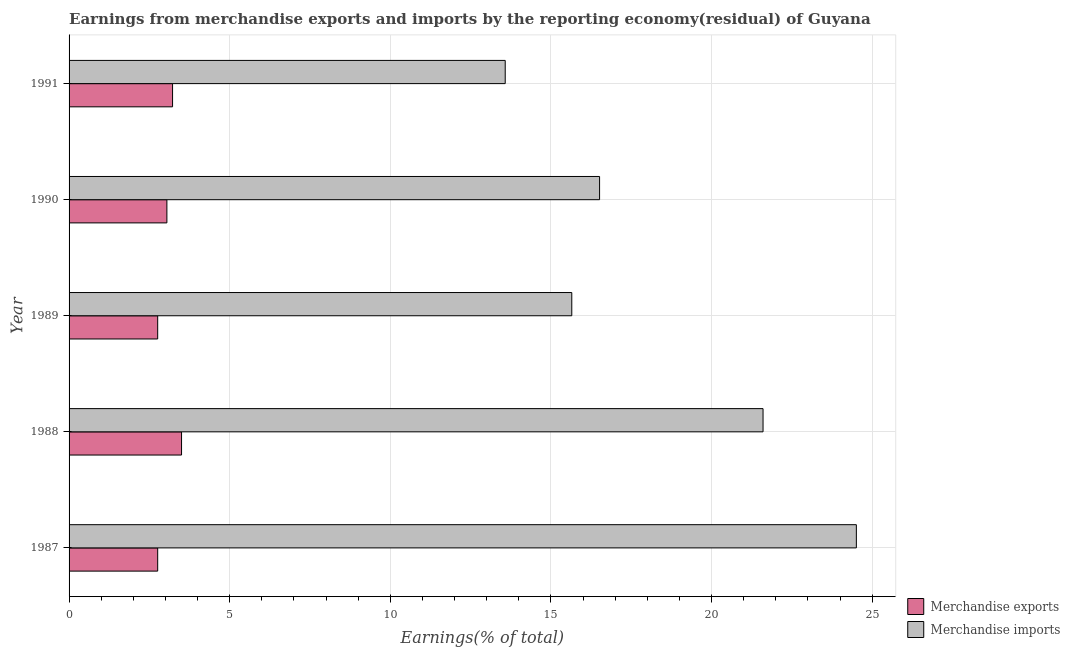How many different coloured bars are there?
Offer a terse response. 2. How many bars are there on the 3rd tick from the bottom?
Offer a very short reply. 2. What is the label of the 5th group of bars from the top?
Ensure brevity in your answer.  1987. In how many cases, is the number of bars for a given year not equal to the number of legend labels?
Your answer should be compact. 0. What is the earnings from merchandise exports in 1990?
Your answer should be very brief. 3.05. Across all years, what is the maximum earnings from merchandise imports?
Give a very brief answer. 24.51. Across all years, what is the minimum earnings from merchandise imports?
Give a very brief answer. 13.58. In which year was the earnings from merchandise exports maximum?
Keep it short and to the point. 1988. What is the total earnings from merchandise exports in the graph?
Provide a short and direct response. 15.28. What is the difference between the earnings from merchandise imports in 1987 and that in 1991?
Offer a terse response. 10.93. What is the difference between the earnings from merchandise exports in 1989 and the earnings from merchandise imports in 1988?
Your answer should be compact. -18.84. What is the average earnings from merchandise imports per year?
Offer a terse response. 18.37. In the year 1988, what is the difference between the earnings from merchandise exports and earnings from merchandise imports?
Offer a very short reply. -18.1. In how many years, is the earnings from merchandise exports greater than 7 %?
Offer a terse response. 0. What is the ratio of the earnings from merchandise exports in 1990 to that in 1991?
Your answer should be very brief. 0.94. Is the difference between the earnings from merchandise exports in 1989 and 1991 greater than the difference between the earnings from merchandise imports in 1989 and 1991?
Offer a very short reply. No. What is the difference between the highest and the second highest earnings from merchandise exports?
Your answer should be compact. 0.28. What is the difference between the highest and the lowest earnings from merchandise exports?
Offer a very short reply. 0.74. What does the 2nd bar from the top in 1990 represents?
Keep it short and to the point. Merchandise exports. Are all the bars in the graph horizontal?
Make the answer very short. Yes. How many years are there in the graph?
Offer a terse response. 5. Are the values on the major ticks of X-axis written in scientific E-notation?
Ensure brevity in your answer.  No. Does the graph contain any zero values?
Your answer should be compact. No. Does the graph contain grids?
Make the answer very short. Yes. How are the legend labels stacked?
Your response must be concise. Vertical. What is the title of the graph?
Your answer should be very brief. Earnings from merchandise exports and imports by the reporting economy(residual) of Guyana. What is the label or title of the X-axis?
Give a very brief answer. Earnings(% of total). What is the Earnings(% of total) of Merchandise exports in 1987?
Ensure brevity in your answer.  2.76. What is the Earnings(% of total) of Merchandise imports in 1987?
Ensure brevity in your answer.  24.51. What is the Earnings(% of total) of Merchandise exports in 1988?
Give a very brief answer. 3.5. What is the Earnings(% of total) in Merchandise imports in 1988?
Your response must be concise. 21.6. What is the Earnings(% of total) of Merchandise exports in 1989?
Your response must be concise. 2.76. What is the Earnings(% of total) in Merchandise imports in 1989?
Your answer should be compact. 15.65. What is the Earnings(% of total) of Merchandise exports in 1990?
Offer a very short reply. 3.05. What is the Earnings(% of total) of Merchandise imports in 1990?
Provide a short and direct response. 16.51. What is the Earnings(% of total) in Merchandise exports in 1991?
Your response must be concise. 3.22. What is the Earnings(% of total) of Merchandise imports in 1991?
Offer a very short reply. 13.58. Across all years, what is the maximum Earnings(% of total) in Merchandise exports?
Your answer should be compact. 3.5. Across all years, what is the maximum Earnings(% of total) of Merchandise imports?
Your response must be concise. 24.51. Across all years, what is the minimum Earnings(% of total) of Merchandise exports?
Provide a succinct answer. 2.76. Across all years, what is the minimum Earnings(% of total) of Merchandise imports?
Ensure brevity in your answer.  13.58. What is the total Earnings(% of total) in Merchandise exports in the graph?
Your response must be concise. 15.28. What is the total Earnings(% of total) in Merchandise imports in the graph?
Your response must be concise. 91.85. What is the difference between the Earnings(% of total) of Merchandise exports in 1987 and that in 1988?
Provide a succinct answer. -0.74. What is the difference between the Earnings(% of total) of Merchandise imports in 1987 and that in 1988?
Your answer should be compact. 2.9. What is the difference between the Earnings(% of total) in Merchandise exports in 1987 and that in 1989?
Ensure brevity in your answer.  -0. What is the difference between the Earnings(% of total) in Merchandise imports in 1987 and that in 1989?
Offer a very short reply. 8.86. What is the difference between the Earnings(% of total) in Merchandise exports in 1987 and that in 1990?
Your answer should be compact. -0.29. What is the difference between the Earnings(% of total) of Merchandise imports in 1987 and that in 1990?
Make the answer very short. 7.99. What is the difference between the Earnings(% of total) in Merchandise exports in 1987 and that in 1991?
Your answer should be very brief. -0.46. What is the difference between the Earnings(% of total) of Merchandise imports in 1987 and that in 1991?
Give a very brief answer. 10.93. What is the difference between the Earnings(% of total) in Merchandise exports in 1988 and that in 1989?
Your response must be concise. 0.74. What is the difference between the Earnings(% of total) of Merchandise imports in 1988 and that in 1989?
Ensure brevity in your answer.  5.95. What is the difference between the Earnings(% of total) of Merchandise exports in 1988 and that in 1990?
Make the answer very short. 0.46. What is the difference between the Earnings(% of total) of Merchandise imports in 1988 and that in 1990?
Provide a short and direct response. 5.09. What is the difference between the Earnings(% of total) in Merchandise exports in 1988 and that in 1991?
Ensure brevity in your answer.  0.28. What is the difference between the Earnings(% of total) in Merchandise imports in 1988 and that in 1991?
Provide a succinct answer. 8.03. What is the difference between the Earnings(% of total) of Merchandise exports in 1989 and that in 1990?
Your answer should be very brief. -0.29. What is the difference between the Earnings(% of total) of Merchandise imports in 1989 and that in 1990?
Offer a terse response. -0.86. What is the difference between the Earnings(% of total) in Merchandise exports in 1989 and that in 1991?
Ensure brevity in your answer.  -0.46. What is the difference between the Earnings(% of total) of Merchandise imports in 1989 and that in 1991?
Give a very brief answer. 2.07. What is the difference between the Earnings(% of total) in Merchandise exports in 1990 and that in 1991?
Provide a short and direct response. -0.18. What is the difference between the Earnings(% of total) in Merchandise imports in 1990 and that in 1991?
Your response must be concise. 2.94. What is the difference between the Earnings(% of total) of Merchandise exports in 1987 and the Earnings(% of total) of Merchandise imports in 1988?
Offer a terse response. -18.84. What is the difference between the Earnings(% of total) of Merchandise exports in 1987 and the Earnings(% of total) of Merchandise imports in 1989?
Ensure brevity in your answer.  -12.89. What is the difference between the Earnings(% of total) in Merchandise exports in 1987 and the Earnings(% of total) in Merchandise imports in 1990?
Ensure brevity in your answer.  -13.75. What is the difference between the Earnings(% of total) of Merchandise exports in 1987 and the Earnings(% of total) of Merchandise imports in 1991?
Ensure brevity in your answer.  -10.82. What is the difference between the Earnings(% of total) of Merchandise exports in 1988 and the Earnings(% of total) of Merchandise imports in 1989?
Your response must be concise. -12.15. What is the difference between the Earnings(% of total) of Merchandise exports in 1988 and the Earnings(% of total) of Merchandise imports in 1990?
Your response must be concise. -13.01. What is the difference between the Earnings(% of total) of Merchandise exports in 1988 and the Earnings(% of total) of Merchandise imports in 1991?
Ensure brevity in your answer.  -10.08. What is the difference between the Earnings(% of total) in Merchandise exports in 1989 and the Earnings(% of total) in Merchandise imports in 1990?
Your answer should be compact. -13.75. What is the difference between the Earnings(% of total) of Merchandise exports in 1989 and the Earnings(% of total) of Merchandise imports in 1991?
Your response must be concise. -10.82. What is the difference between the Earnings(% of total) in Merchandise exports in 1990 and the Earnings(% of total) in Merchandise imports in 1991?
Offer a very short reply. -10.53. What is the average Earnings(% of total) of Merchandise exports per year?
Offer a terse response. 3.06. What is the average Earnings(% of total) in Merchandise imports per year?
Provide a succinct answer. 18.37. In the year 1987, what is the difference between the Earnings(% of total) of Merchandise exports and Earnings(% of total) of Merchandise imports?
Keep it short and to the point. -21.75. In the year 1988, what is the difference between the Earnings(% of total) of Merchandise exports and Earnings(% of total) of Merchandise imports?
Make the answer very short. -18.1. In the year 1989, what is the difference between the Earnings(% of total) in Merchandise exports and Earnings(% of total) in Merchandise imports?
Your answer should be compact. -12.89. In the year 1990, what is the difference between the Earnings(% of total) of Merchandise exports and Earnings(% of total) of Merchandise imports?
Offer a terse response. -13.47. In the year 1991, what is the difference between the Earnings(% of total) in Merchandise exports and Earnings(% of total) in Merchandise imports?
Provide a succinct answer. -10.35. What is the ratio of the Earnings(% of total) in Merchandise exports in 1987 to that in 1988?
Offer a very short reply. 0.79. What is the ratio of the Earnings(% of total) of Merchandise imports in 1987 to that in 1988?
Your answer should be very brief. 1.13. What is the ratio of the Earnings(% of total) in Merchandise exports in 1987 to that in 1989?
Your answer should be compact. 1. What is the ratio of the Earnings(% of total) in Merchandise imports in 1987 to that in 1989?
Your response must be concise. 1.57. What is the ratio of the Earnings(% of total) of Merchandise exports in 1987 to that in 1990?
Make the answer very short. 0.91. What is the ratio of the Earnings(% of total) in Merchandise imports in 1987 to that in 1990?
Offer a terse response. 1.48. What is the ratio of the Earnings(% of total) in Merchandise exports in 1987 to that in 1991?
Your answer should be compact. 0.86. What is the ratio of the Earnings(% of total) of Merchandise imports in 1987 to that in 1991?
Provide a succinct answer. 1.81. What is the ratio of the Earnings(% of total) in Merchandise exports in 1988 to that in 1989?
Offer a terse response. 1.27. What is the ratio of the Earnings(% of total) of Merchandise imports in 1988 to that in 1989?
Keep it short and to the point. 1.38. What is the ratio of the Earnings(% of total) in Merchandise exports in 1988 to that in 1990?
Provide a succinct answer. 1.15. What is the ratio of the Earnings(% of total) in Merchandise imports in 1988 to that in 1990?
Provide a succinct answer. 1.31. What is the ratio of the Earnings(% of total) of Merchandise exports in 1988 to that in 1991?
Offer a terse response. 1.09. What is the ratio of the Earnings(% of total) in Merchandise imports in 1988 to that in 1991?
Make the answer very short. 1.59. What is the ratio of the Earnings(% of total) of Merchandise exports in 1989 to that in 1990?
Provide a short and direct response. 0.91. What is the ratio of the Earnings(% of total) of Merchandise imports in 1989 to that in 1990?
Keep it short and to the point. 0.95. What is the ratio of the Earnings(% of total) in Merchandise exports in 1989 to that in 1991?
Ensure brevity in your answer.  0.86. What is the ratio of the Earnings(% of total) of Merchandise imports in 1989 to that in 1991?
Offer a terse response. 1.15. What is the ratio of the Earnings(% of total) of Merchandise exports in 1990 to that in 1991?
Keep it short and to the point. 0.95. What is the ratio of the Earnings(% of total) in Merchandise imports in 1990 to that in 1991?
Offer a very short reply. 1.22. What is the difference between the highest and the second highest Earnings(% of total) of Merchandise exports?
Your answer should be very brief. 0.28. What is the difference between the highest and the second highest Earnings(% of total) of Merchandise imports?
Provide a short and direct response. 2.9. What is the difference between the highest and the lowest Earnings(% of total) of Merchandise exports?
Make the answer very short. 0.74. What is the difference between the highest and the lowest Earnings(% of total) of Merchandise imports?
Give a very brief answer. 10.93. 